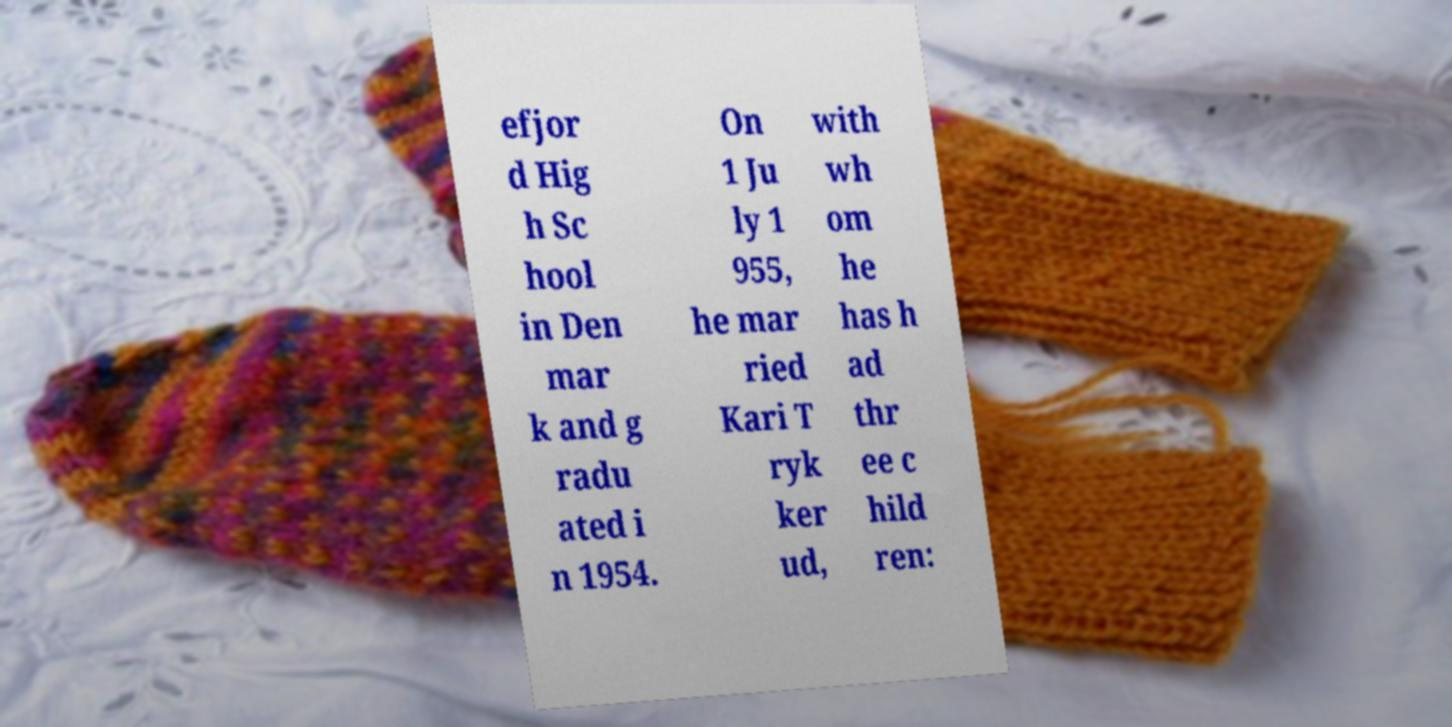Can you read and provide the text displayed in the image?This photo seems to have some interesting text. Can you extract and type it out for me? efjor d Hig h Sc hool in Den mar k and g radu ated i n 1954. On 1 Ju ly 1 955, he mar ried Kari T ryk ker ud, with wh om he has h ad thr ee c hild ren: 